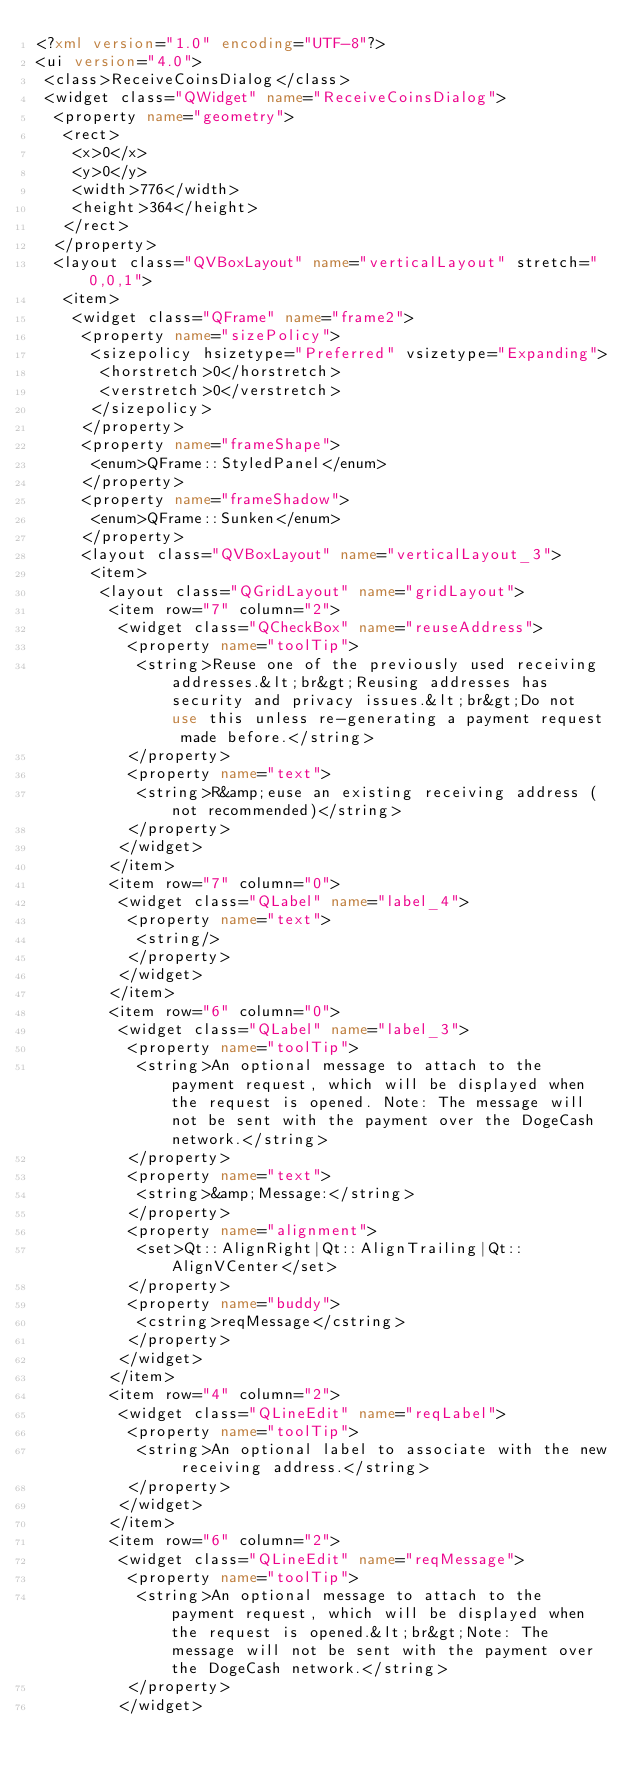Convert code to text. <code><loc_0><loc_0><loc_500><loc_500><_XML_><?xml version="1.0" encoding="UTF-8"?>
<ui version="4.0">
 <class>ReceiveCoinsDialog</class>
 <widget class="QWidget" name="ReceiveCoinsDialog">
  <property name="geometry">
   <rect>
    <x>0</x>
    <y>0</y>
    <width>776</width>
    <height>364</height>
   </rect>
  </property>
  <layout class="QVBoxLayout" name="verticalLayout" stretch="0,0,1">
   <item>
    <widget class="QFrame" name="frame2">
     <property name="sizePolicy">
      <sizepolicy hsizetype="Preferred" vsizetype="Expanding">
       <horstretch>0</horstretch>
       <verstretch>0</verstretch>
      </sizepolicy>
     </property>
     <property name="frameShape">
      <enum>QFrame::StyledPanel</enum>
     </property>
     <property name="frameShadow">
      <enum>QFrame::Sunken</enum>
     </property>
     <layout class="QVBoxLayout" name="verticalLayout_3">
      <item>
       <layout class="QGridLayout" name="gridLayout">
        <item row="7" column="2">
         <widget class="QCheckBox" name="reuseAddress">
          <property name="toolTip">
           <string>Reuse one of the previously used receiving addresses.&lt;br&gt;Reusing addresses has security and privacy issues.&lt;br&gt;Do not use this unless re-generating a payment request made before.</string>
          </property>
          <property name="text">
           <string>R&amp;euse an existing receiving address (not recommended)</string>
          </property>
         </widget>
        </item>
        <item row="7" column="0">
         <widget class="QLabel" name="label_4">
          <property name="text">
           <string/>
          </property>
         </widget>
        </item>
        <item row="6" column="0">
         <widget class="QLabel" name="label_3">
          <property name="toolTip">
           <string>An optional message to attach to the payment request, which will be displayed when the request is opened. Note: The message will not be sent with the payment over the DogeCash network.</string>
          </property>
          <property name="text">
           <string>&amp;Message:</string>
          </property>
          <property name="alignment">
           <set>Qt::AlignRight|Qt::AlignTrailing|Qt::AlignVCenter</set>
          </property>
          <property name="buddy">
           <cstring>reqMessage</cstring>
          </property>
         </widget>
        </item>
        <item row="4" column="2">
         <widget class="QLineEdit" name="reqLabel">
          <property name="toolTip">
           <string>An optional label to associate with the new receiving address.</string>
          </property>
         </widget>
        </item>
        <item row="6" column="2">
         <widget class="QLineEdit" name="reqMessage">
          <property name="toolTip">
           <string>An optional message to attach to the payment request, which will be displayed when the request is opened.&lt;br&gt;Note: The message will not be sent with the payment over the DogeCash network.</string>
          </property>
         </widget></code> 